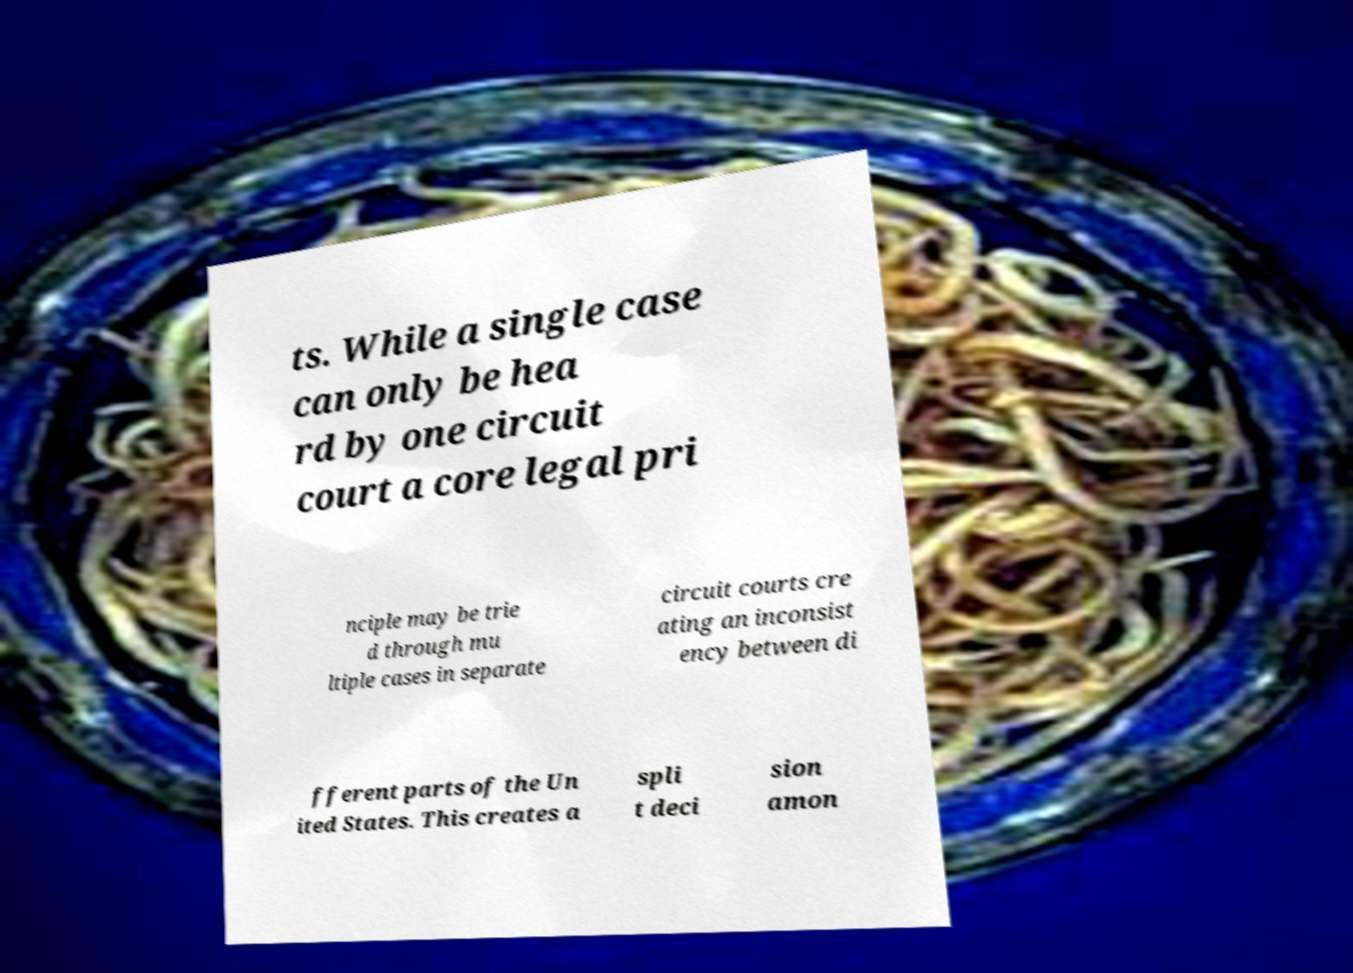Could you assist in decoding the text presented in this image and type it out clearly? ts. While a single case can only be hea rd by one circuit court a core legal pri nciple may be trie d through mu ltiple cases in separate circuit courts cre ating an inconsist ency between di fferent parts of the Un ited States. This creates a spli t deci sion amon 